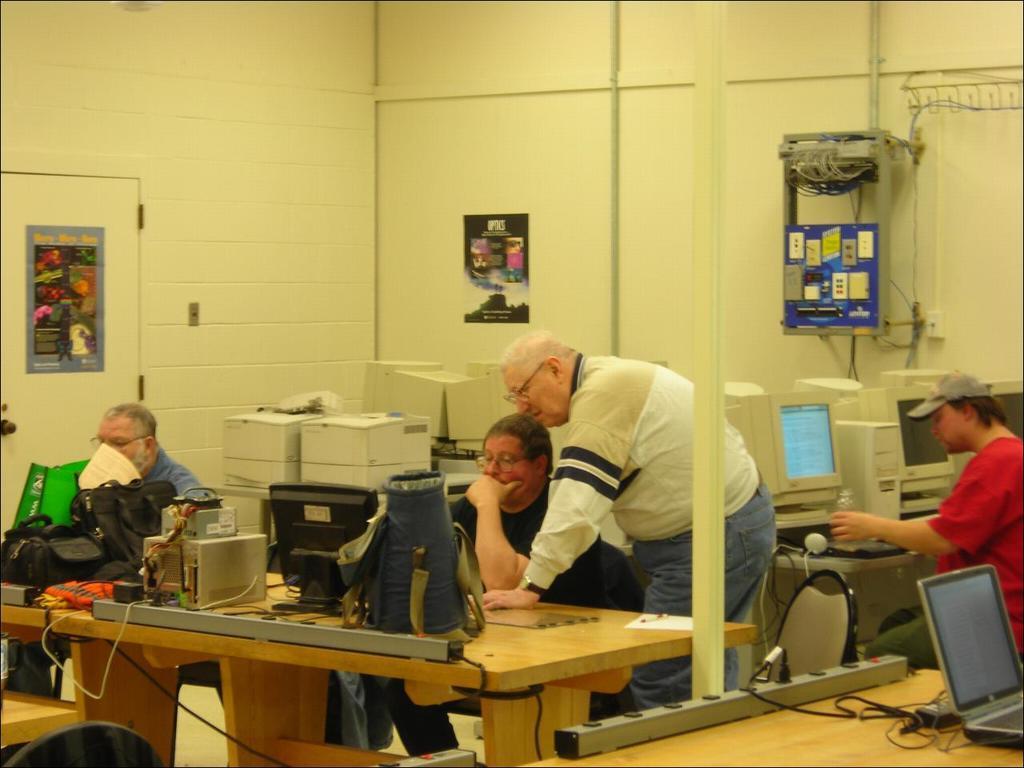Can you describe this image briefly? It looks like a computer lab,there are lot of computers in the image and there are total four people, three of them are sitting and one person is standing beside a black color shirt person,in the background there are also some monitors and a white color wall and some posters to the wall to its right side there are many wires. 